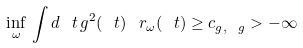<formula> <loc_0><loc_0><loc_500><loc_500>\inf _ { \omega } \, \int d \ t \, g ^ { 2 } ( \ t ) \ r _ { \omega } ( \ t ) \geq c _ { g , \ g } > - \infty</formula> 